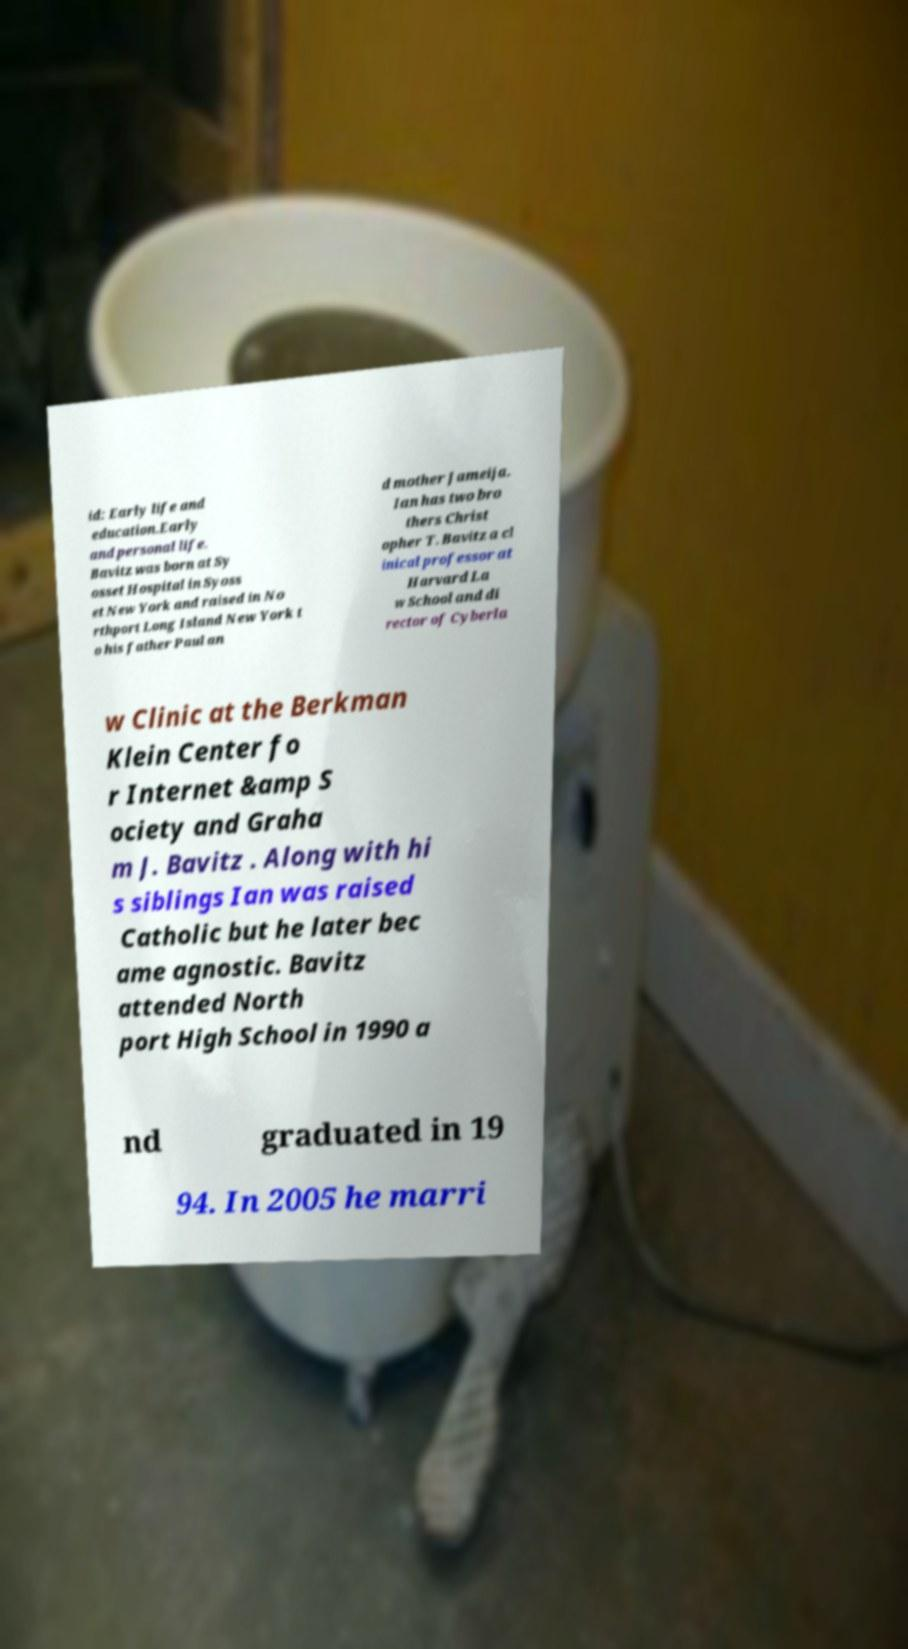Could you assist in decoding the text presented in this image and type it out clearly? id: Early life and education.Early and personal life. Bavitz was born at Sy osset Hospital in Syoss et New York and raised in No rthport Long Island New York t o his father Paul an d mother Jameija. Ian has two bro thers Christ opher T. Bavitz a cl inical professor at Harvard La w School and di rector of Cyberla w Clinic at the Berkman Klein Center fo r Internet &amp S ociety and Graha m J. Bavitz . Along with hi s siblings Ian was raised Catholic but he later bec ame agnostic. Bavitz attended North port High School in 1990 a nd graduated in 19 94. In 2005 he marri 